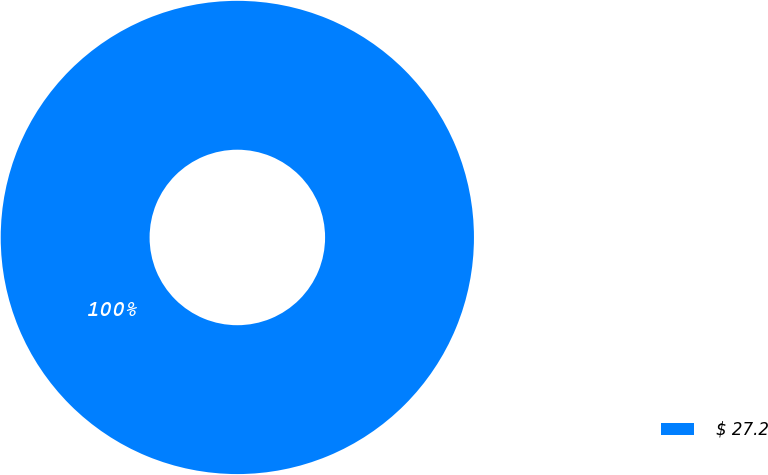Convert chart. <chart><loc_0><loc_0><loc_500><loc_500><pie_chart><fcel>$ 27.2<nl><fcel>100.0%<nl></chart> 